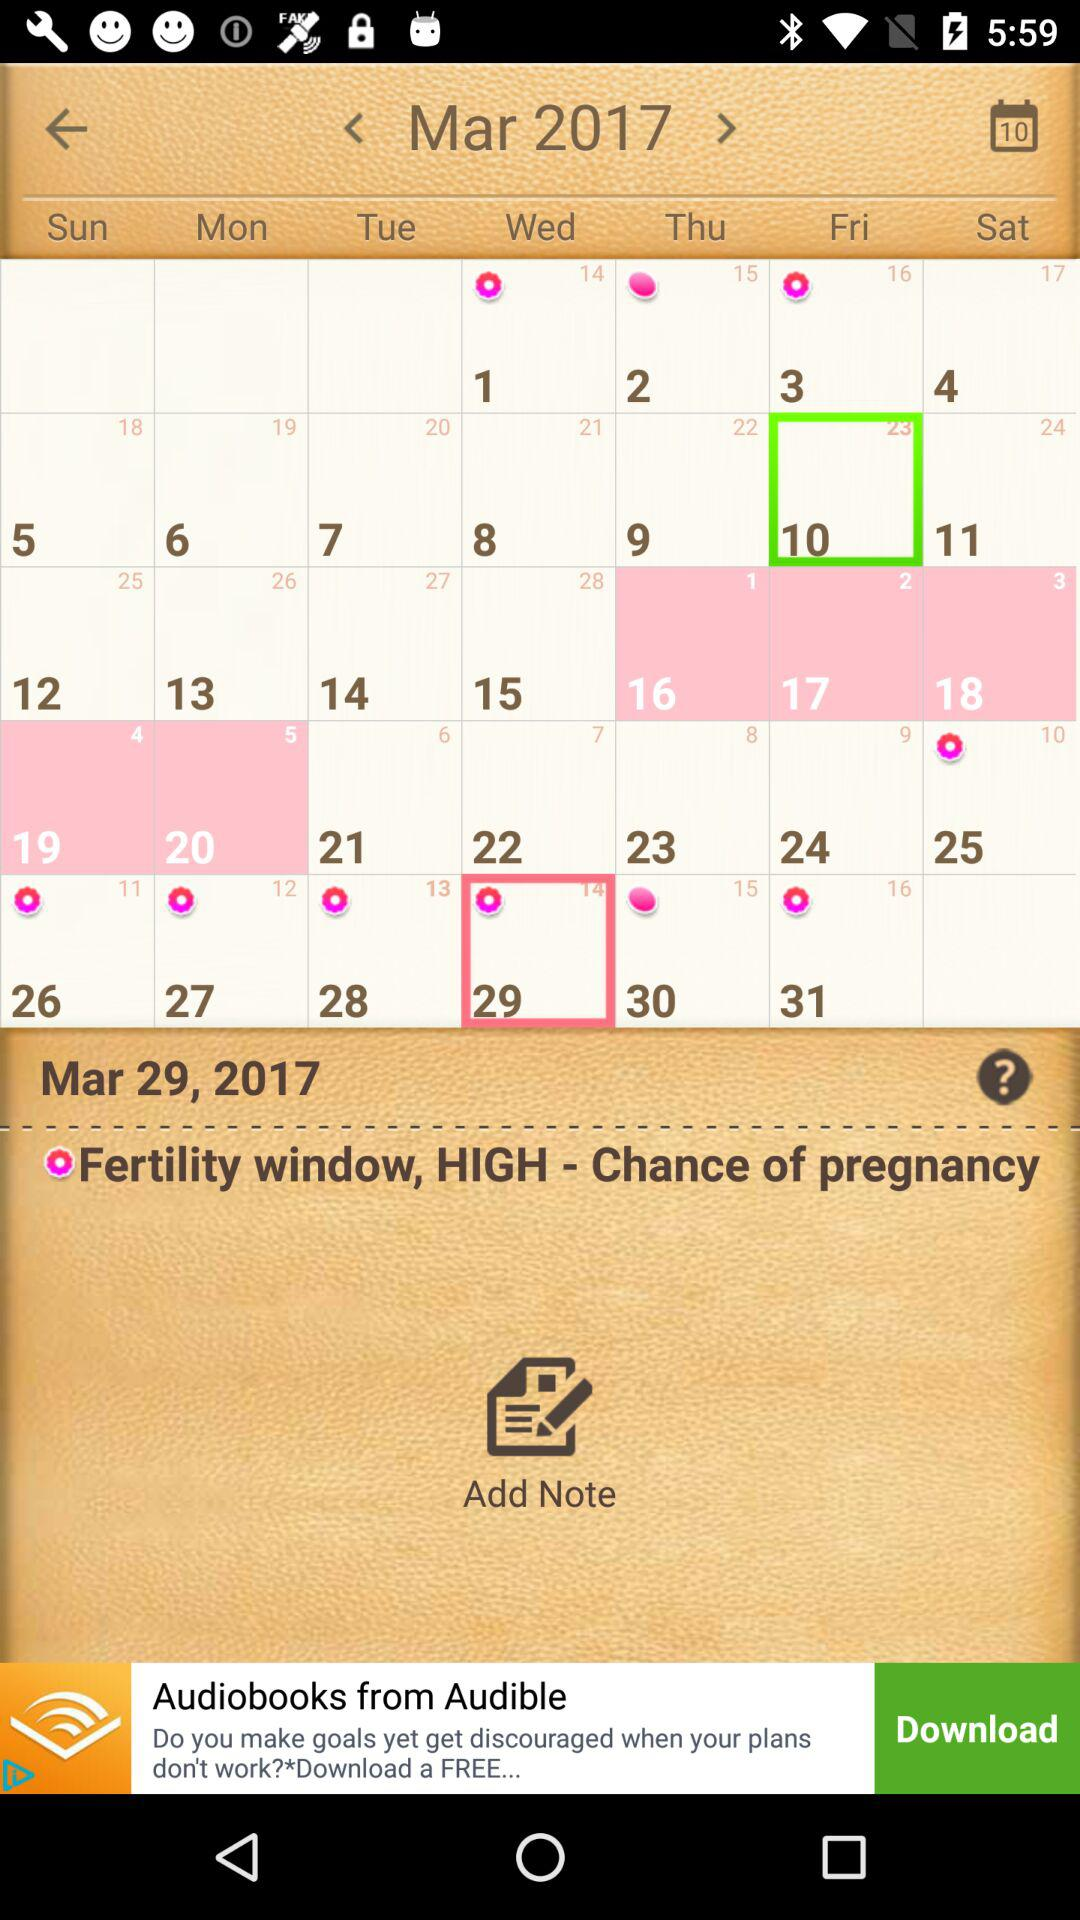Which month's calendar is this? This is March's calendar. 